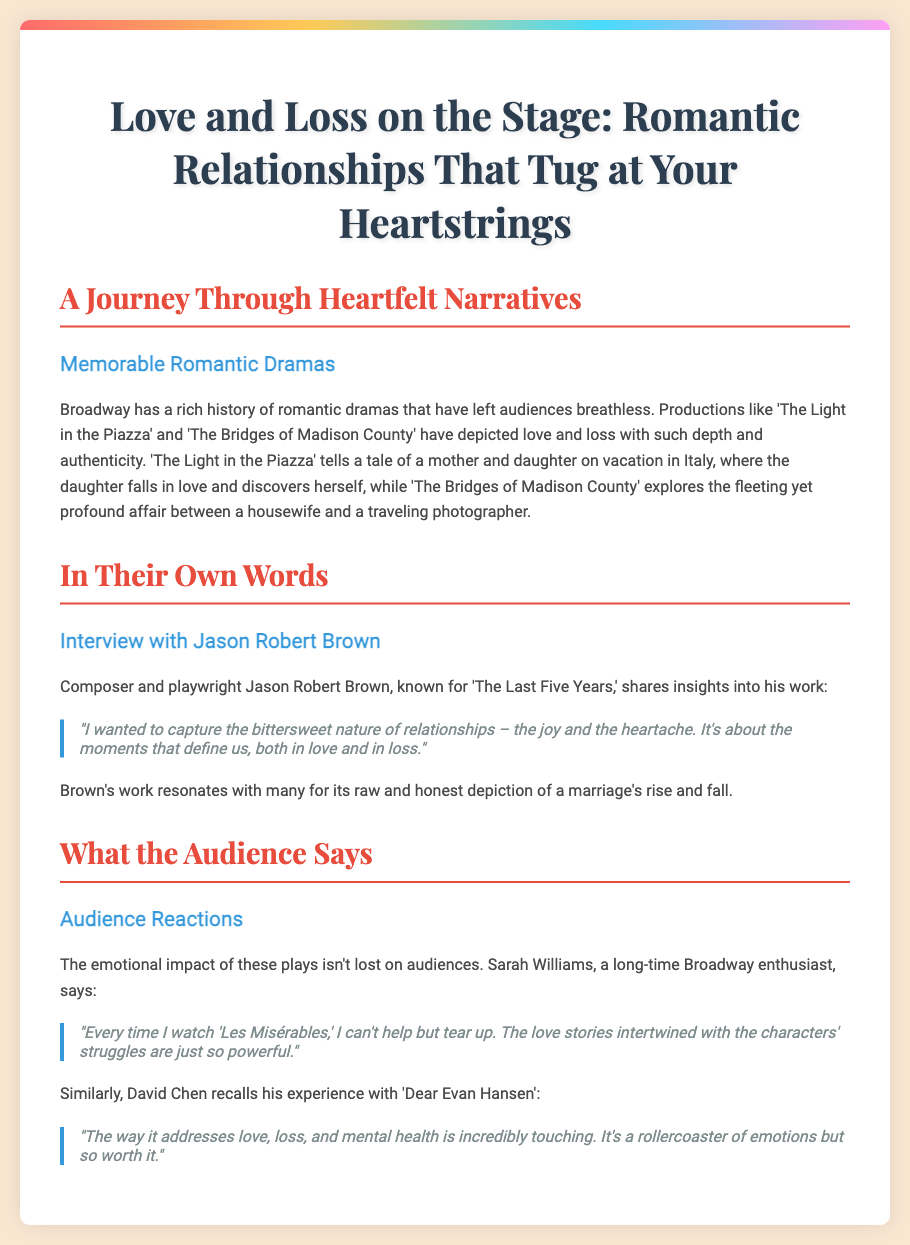What are some memorable romantic dramas mentioned? The document lists 'The Light in the Piazza' and 'The Bridges of Madison County' as memorable romantic dramas.
Answer: 'The Light in the Piazza', 'The Bridges of Madison County' Who is interviewed in the Playbill? The interview features composer and playwright Jason Robert Brown.
Answer: Jason Robert Brown What work is Jason Robert Brown known for? Jason Robert Brown is known for 'The Last Five Years.'
Answer: 'The Last Five Years' What emotional response does Sarah Williams associate with 'Les Misérables'? Sarah Williams associates tearing up as her emotional response while watching 'Les Misérables.'
Answer: Tear up What theme does David Chen mention in 'Dear Evan Hansen'? David Chen mentions that 'Dear Evan Hansen' addresses love, loss, and mental health.
Answer: Love, loss, and mental health How does Jason Robert Brown describe relationships? Jason Robert Brown describes relationships as having a bittersweet nature, encompassing joy and heartache.
Answer: Bittersweet nature What is the key focus of 'The Light in the Piazza'? The key focus is on a mother and daughter on vacation in Italy and the daughter's self-discovery through love.
Answer: A mother and daughter on vacation in Italy What kind of emotional impact do the plays have on the audience? The plays have a powerful emotional impact on the audience, as indicated by various reactions.
Answer: Powerful emotional impact 